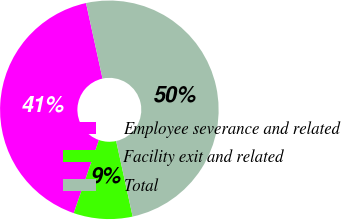Convert chart. <chart><loc_0><loc_0><loc_500><loc_500><pie_chart><fcel>Employee severance and related<fcel>Facility exit and related<fcel>Total<nl><fcel>41.3%<fcel>8.7%<fcel>50.0%<nl></chart> 